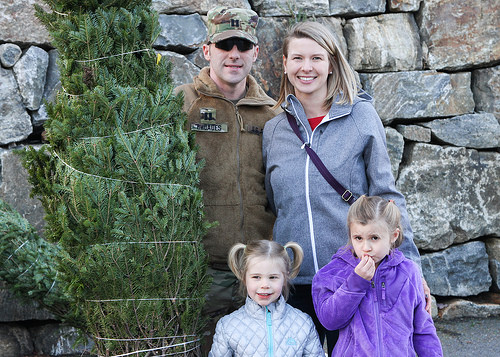<image>
Is the tree to the right of the women? Yes. From this viewpoint, the tree is positioned to the right side relative to the women. Is the woman next to the tree? No. The woman is not positioned next to the tree. They are located in different areas of the scene. Where is the man in relation to the girl? Is it in front of the girl? No. The man is not in front of the girl. The spatial positioning shows a different relationship between these objects. 